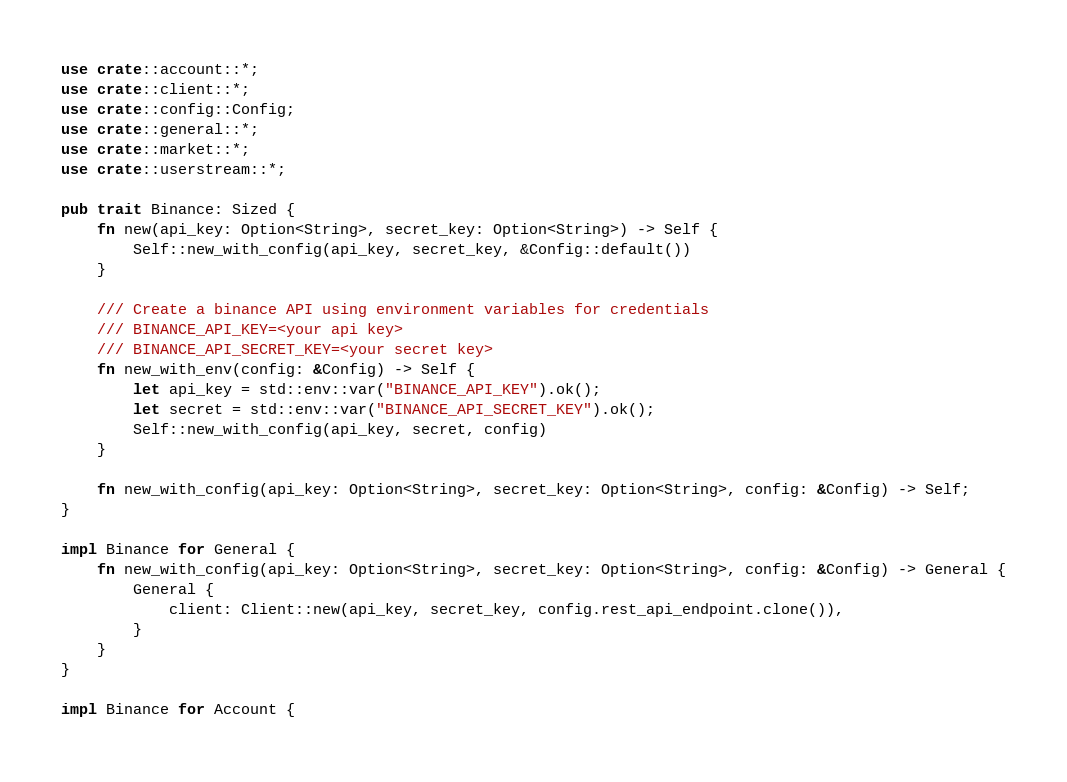<code> <loc_0><loc_0><loc_500><loc_500><_Rust_>use crate::account::*;
use crate::client::*;
use crate::config::Config;
use crate::general::*;
use crate::market::*;
use crate::userstream::*;

pub trait Binance: Sized {
    fn new(api_key: Option<String>, secret_key: Option<String>) -> Self {
        Self::new_with_config(api_key, secret_key, &Config::default())
    }

    /// Create a binance API using environment variables for credentials
    /// BINANCE_API_KEY=<your api key>
    /// BINANCE_API_SECRET_KEY=<your secret key>
    fn new_with_env(config: &Config) -> Self {
        let api_key = std::env::var("BINANCE_API_KEY").ok();
        let secret = std::env::var("BINANCE_API_SECRET_KEY").ok();
        Self::new_with_config(api_key, secret, config)
    }

    fn new_with_config(api_key: Option<String>, secret_key: Option<String>, config: &Config) -> Self;
}

impl Binance for General {
    fn new_with_config(api_key: Option<String>, secret_key: Option<String>, config: &Config) -> General {
        General {
            client: Client::new(api_key, secret_key, config.rest_api_endpoint.clone()),
        }
    }
}

impl Binance for Account {</code> 